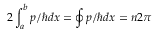Convert formula to latex. <formula><loc_0><loc_0><loc_500><loc_500>2 \int _ { a } ^ { b } p / \hbar { d } x = \oint p / \hbar { d } x = n 2 \pi</formula> 